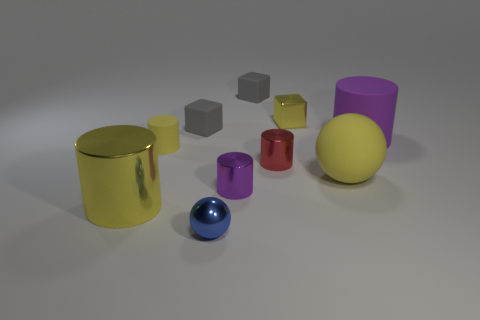Subtract all gray blocks. How many blocks are left? 1 Subtract all cyan cylinders. How many gray blocks are left? 2 Subtract 3 cylinders. How many cylinders are left? 2 Subtract all red cylinders. How many cylinders are left? 4 Subtract all red cylinders. Subtract all blue spheres. How many cylinders are left? 4 Subtract all cubes. How many objects are left? 7 Subtract 1 blue balls. How many objects are left? 9 Subtract all large purple cylinders. Subtract all tiny blue metal balls. How many objects are left? 8 Add 7 tiny yellow objects. How many tiny yellow objects are left? 9 Add 6 tiny purple shiny things. How many tiny purple shiny things exist? 7 